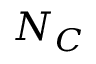<formula> <loc_0><loc_0><loc_500><loc_500>N _ { C }</formula> 